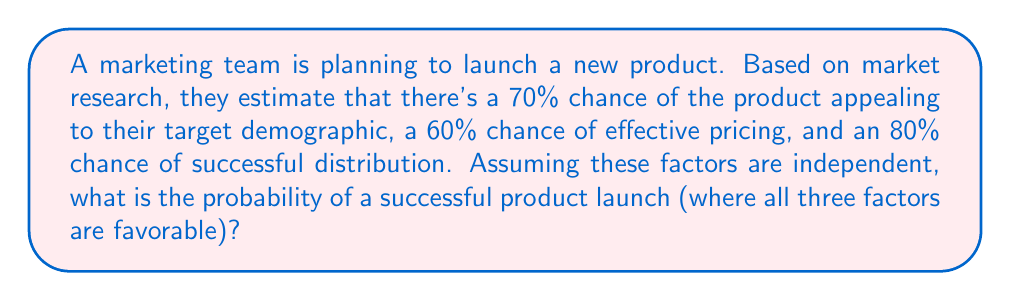What is the answer to this math problem? To solve this problem, we need to use the multiplication rule of probability for independent events. Since we're looking for the probability of all three factors being favorable, we multiply the individual probabilities:

Let's define our events:
A: Product appeals to target demographic (P(A) = 0.70)
B: Effective pricing (P(B) = 0.60)
C: Successful distribution (P(C) = 0.80)

We want to find P(A and B and C):

$$ P(A \text{ and } B \text{ and } C) = P(A) \times P(B) \times P(C) $$

Substituting the given probabilities:

$$ P(\text{Successful Launch}) = 0.70 \times 0.60 \times 0.80 $$

Calculating:

$$ P(\text{Successful Launch}) = 0.336 $$

To convert to a percentage, we multiply by 100:

$$ P(\text{Successful Launch}) = 0.336 \times 100 = 33.6\% $$

Therefore, the probability of a successful product launch, where all three factors are favorable, is 33.6%.
Answer: 33.6% 